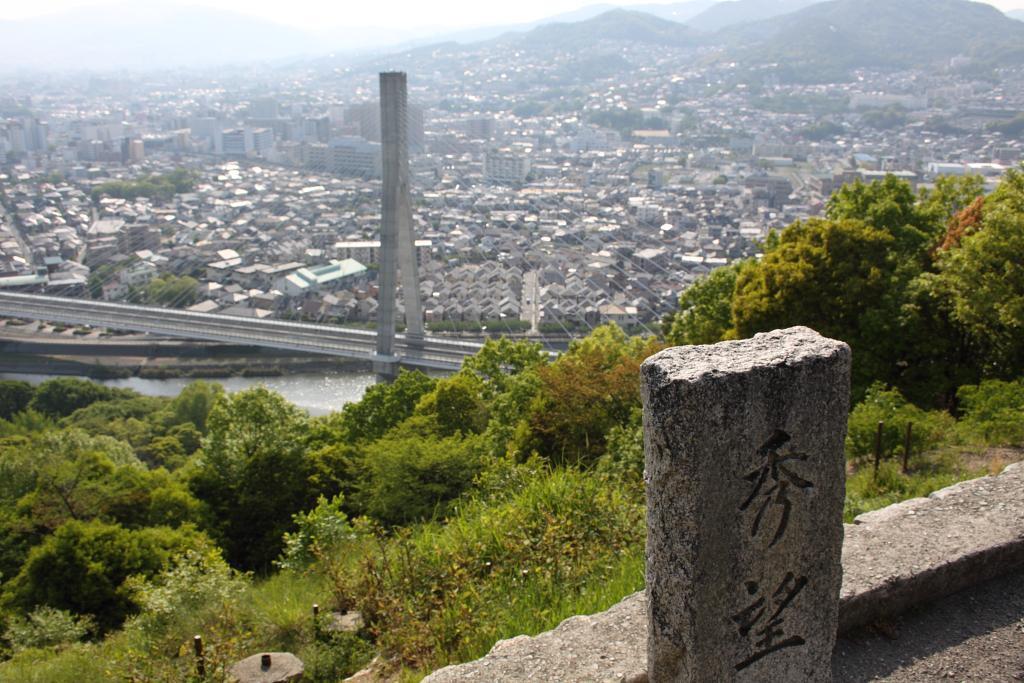Can you describe this image briefly? This picture shows a bunch of buildings and we see trees and a cloudy sky and hills and a stone. 